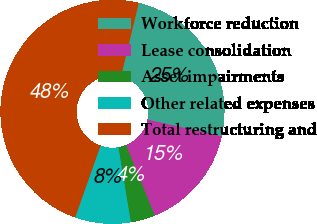Convert chart. <chart><loc_0><loc_0><loc_500><loc_500><pie_chart><fcel>Workforce reduction<fcel>Lease consolidation<fcel>Asset impairments<fcel>Other related expenses<fcel>Total restructuring and<nl><fcel>24.76%<fcel>15.33%<fcel>3.54%<fcel>8.02%<fcel>48.35%<nl></chart> 